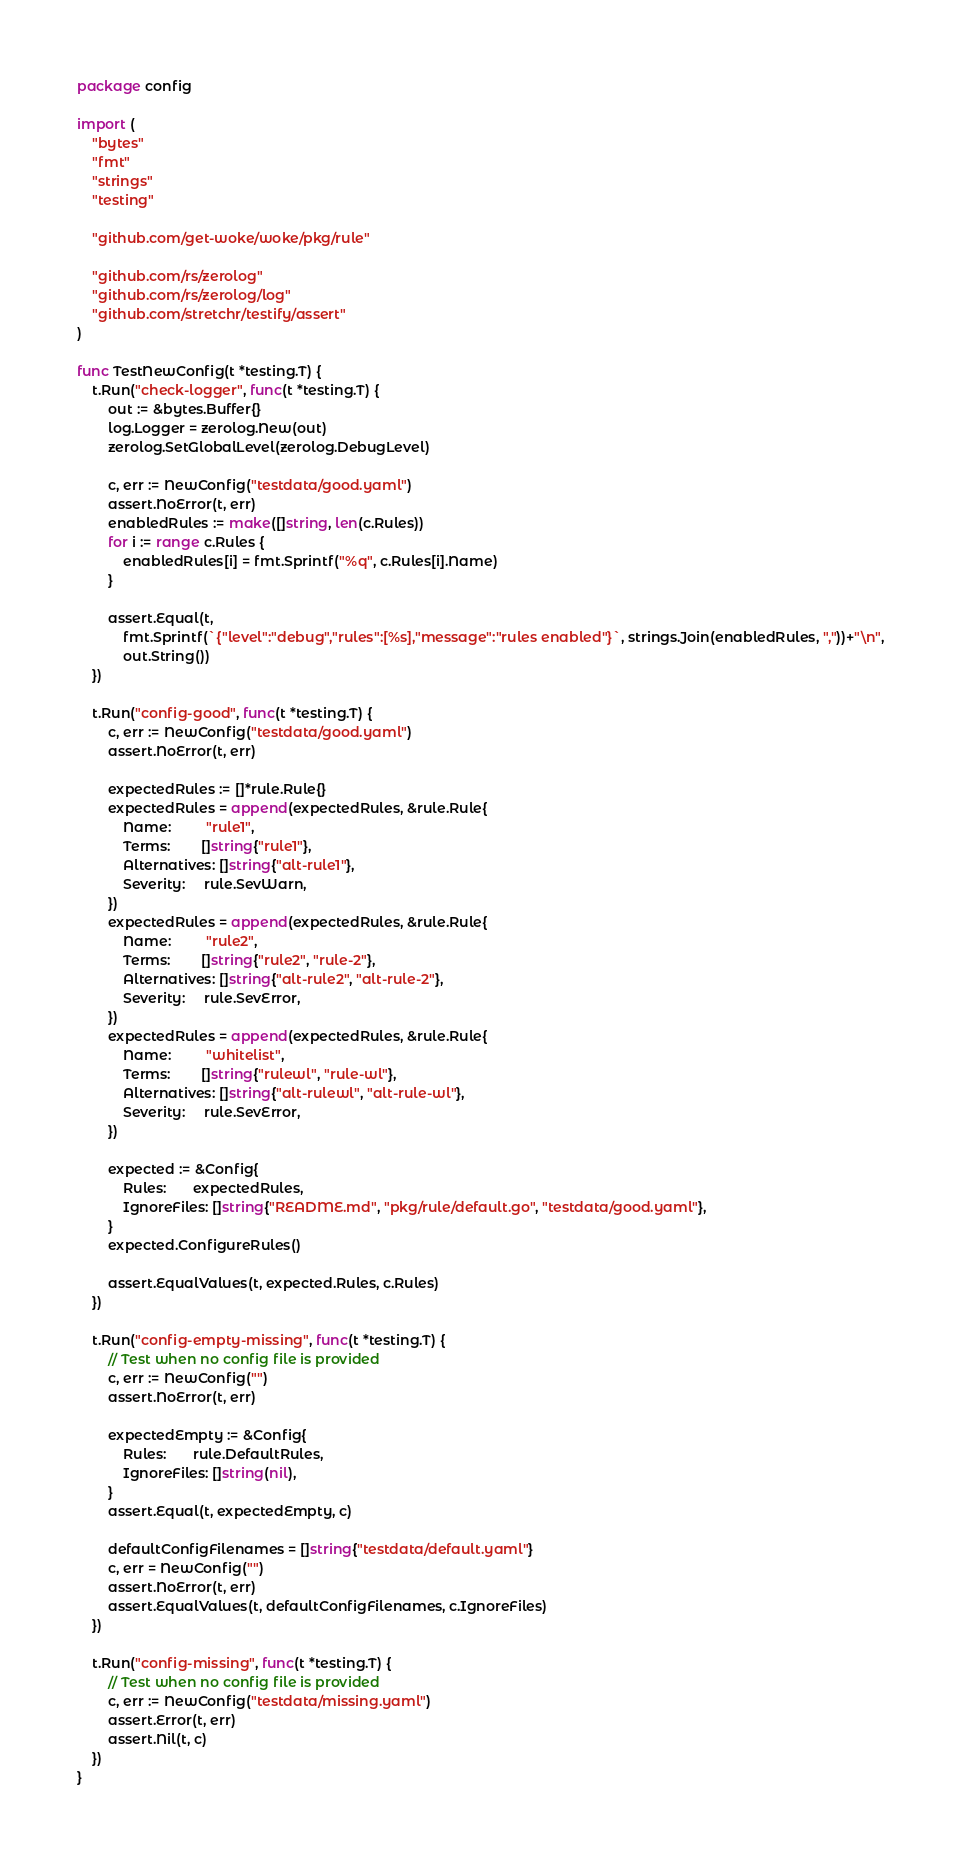<code> <loc_0><loc_0><loc_500><loc_500><_Go_>package config

import (
	"bytes"
	"fmt"
	"strings"
	"testing"

	"github.com/get-woke/woke/pkg/rule"

	"github.com/rs/zerolog"
	"github.com/rs/zerolog/log"
	"github.com/stretchr/testify/assert"
)

func TestNewConfig(t *testing.T) {
	t.Run("check-logger", func(t *testing.T) {
		out := &bytes.Buffer{}
		log.Logger = zerolog.New(out)
		zerolog.SetGlobalLevel(zerolog.DebugLevel)

		c, err := NewConfig("testdata/good.yaml")
		assert.NoError(t, err)
		enabledRules := make([]string, len(c.Rules))
		for i := range c.Rules {
			enabledRules[i] = fmt.Sprintf("%q", c.Rules[i].Name)
		}

		assert.Equal(t,
			fmt.Sprintf(`{"level":"debug","rules":[%s],"message":"rules enabled"}`, strings.Join(enabledRules, ","))+"\n",
			out.String())
	})

	t.Run("config-good", func(t *testing.T) {
		c, err := NewConfig("testdata/good.yaml")
		assert.NoError(t, err)

		expectedRules := []*rule.Rule{}
		expectedRules = append(expectedRules, &rule.Rule{
			Name:         "rule1",
			Terms:        []string{"rule1"},
			Alternatives: []string{"alt-rule1"},
			Severity:     rule.SevWarn,
		})
		expectedRules = append(expectedRules, &rule.Rule{
			Name:         "rule2",
			Terms:        []string{"rule2", "rule-2"},
			Alternatives: []string{"alt-rule2", "alt-rule-2"},
			Severity:     rule.SevError,
		})
		expectedRules = append(expectedRules, &rule.Rule{
			Name:         "whitelist",
			Terms:        []string{"rulewl", "rule-wl"},
			Alternatives: []string{"alt-rulewl", "alt-rule-wl"},
			Severity:     rule.SevError,
		})

		expected := &Config{
			Rules:       expectedRules,
			IgnoreFiles: []string{"README.md", "pkg/rule/default.go", "testdata/good.yaml"},
		}
		expected.ConfigureRules()

		assert.EqualValues(t, expected.Rules, c.Rules)
	})

	t.Run("config-empty-missing", func(t *testing.T) {
		// Test when no config file is provided
		c, err := NewConfig("")
		assert.NoError(t, err)

		expectedEmpty := &Config{
			Rules:       rule.DefaultRules,
			IgnoreFiles: []string(nil),
		}
		assert.Equal(t, expectedEmpty, c)

		defaultConfigFilenames = []string{"testdata/default.yaml"}
		c, err = NewConfig("")
		assert.NoError(t, err)
		assert.EqualValues(t, defaultConfigFilenames, c.IgnoreFiles)
	})

	t.Run("config-missing", func(t *testing.T) {
		// Test when no config file is provided
		c, err := NewConfig("testdata/missing.yaml")
		assert.Error(t, err)
		assert.Nil(t, c)
	})
}
</code> 